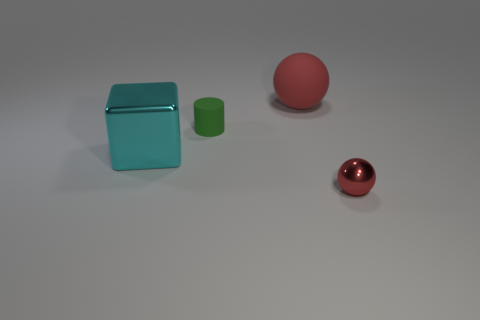Subtract 1 cylinders. How many cylinders are left? 0 Subtract all yellow blocks. How many blue cylinders are left? 0 Add 2 red cubes. How many objects exist? 6 Subtract all small red metal objects. Subtract all small green cylinders. How many objects are left? 2 Add 3 green objects. How many green objects are left? 4 Add 3 small green cylinders. How many small green cylinders exist? 4 Subtract 0 blue balls. How many objects are left? 4 Subtract all yellow cubes. Subtract all cyan cylinders. How many cubes are left? 1 